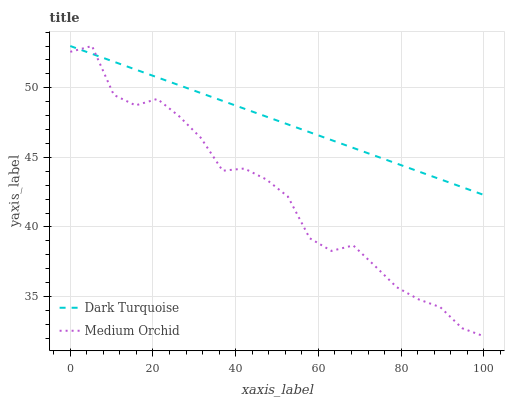Does Medium Orchid have the maximum area under the curve?
Answer yes or no. No. Is Medium Orchid the smoothest?
Answer yes or no. No. 